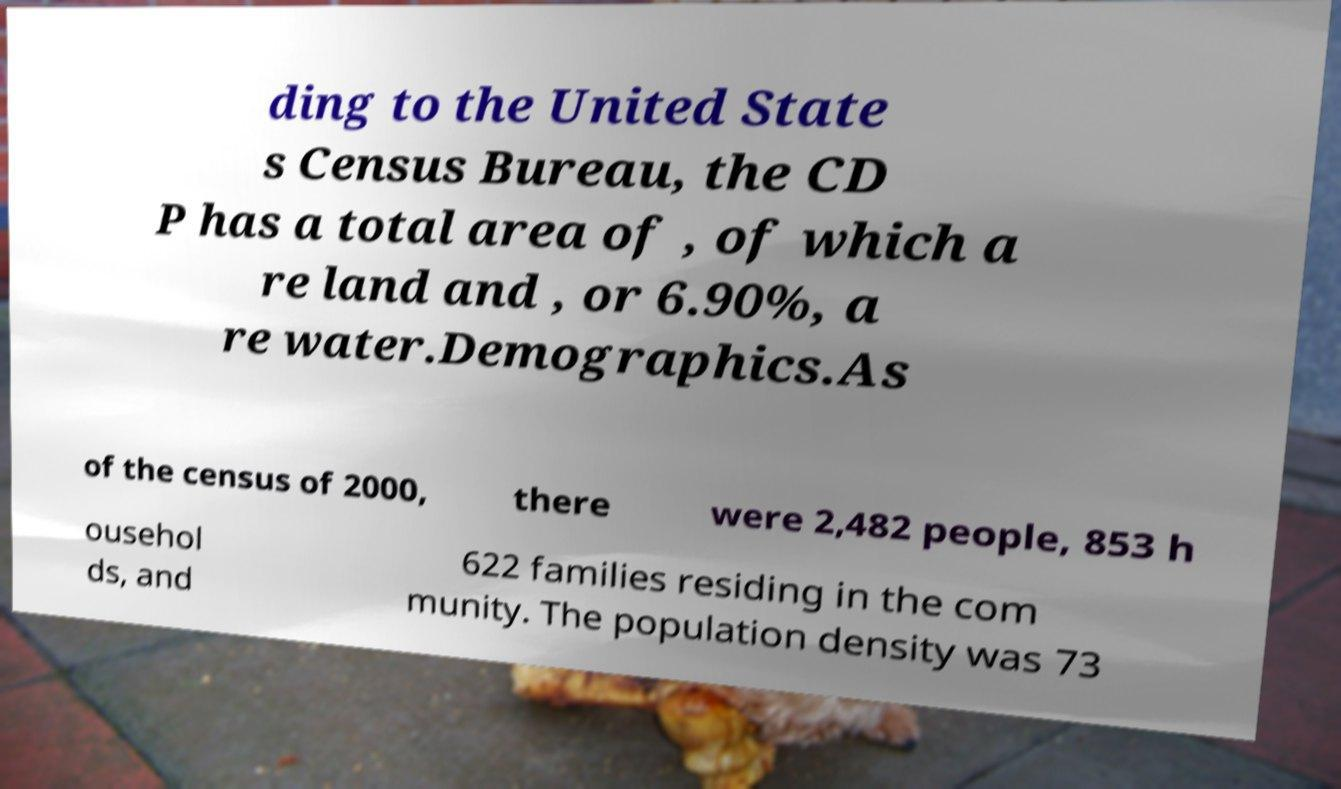Please read and relay the text visible in this image. What does it say? ding to the United State s Census Bureau, the CD P has a total area of , of which a re land and , or 6.90%, a re water.Demographics.As of the census of 2000, there were 2,482 people, 853 h ousehol ds, and 622 families residing in the com munity. The population density was 73 